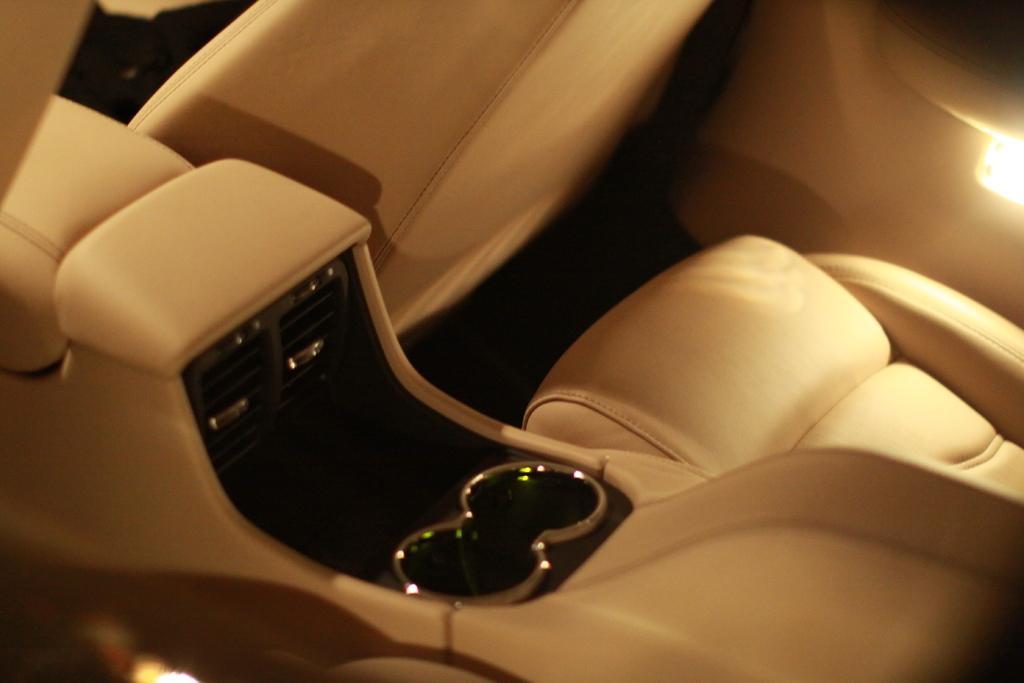Describe this image in one or two sentences. It is an inside part of a car, these are the seats, in the right side there is a light. 